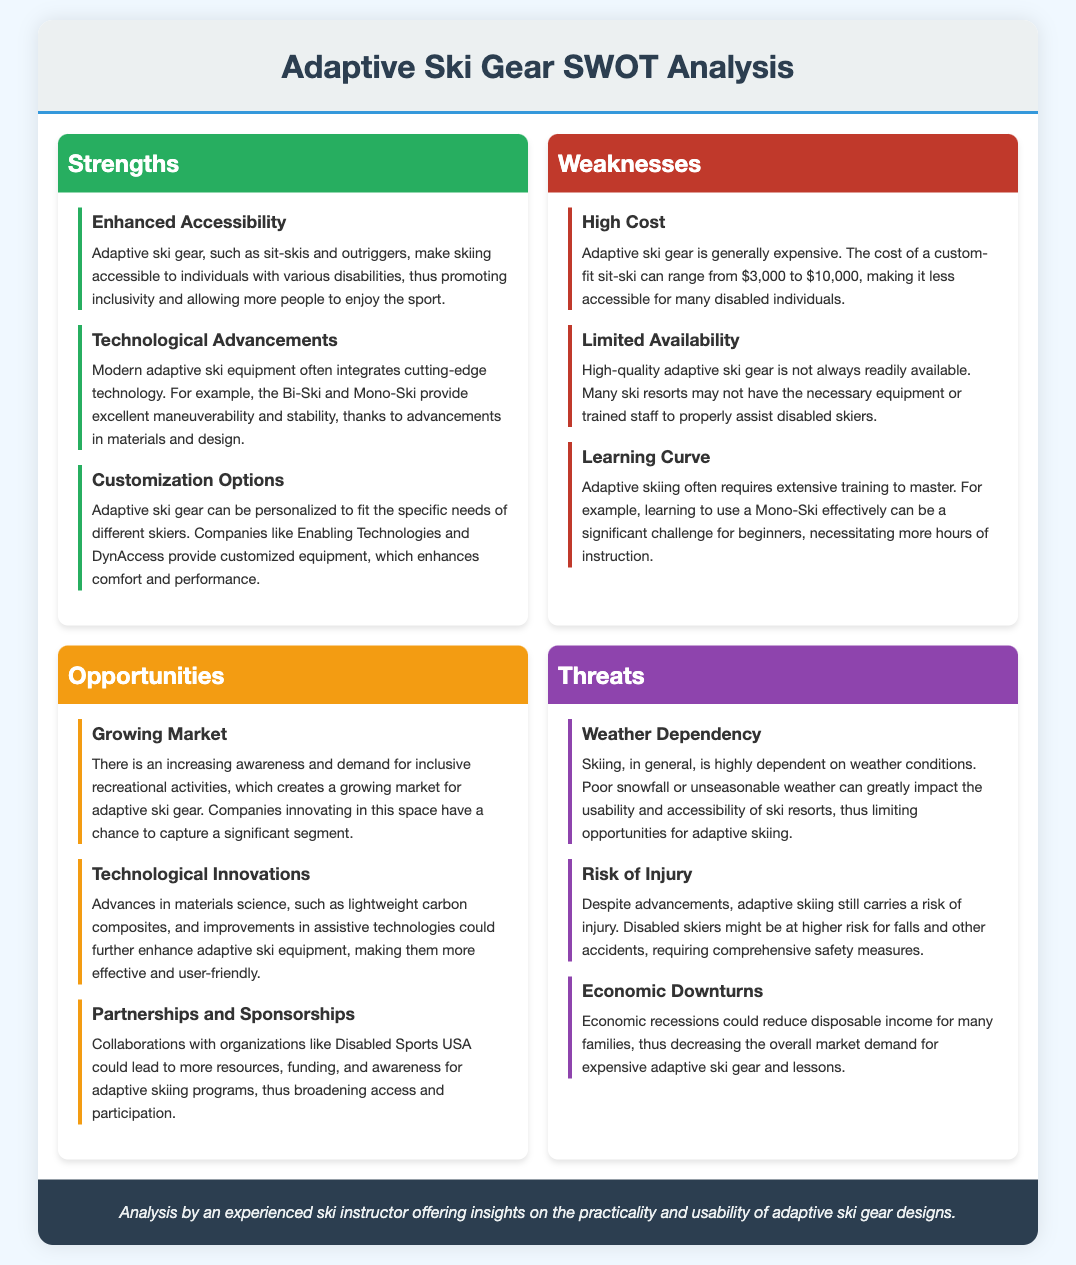What is a key benefit of adaptive ski gear? Enhanced accessibility is highlighted as a significant advantage of adaptive ski gear, making skiing enjoyable for individuals with disabilities.
Answer: Enhanced accessibility What is the cost range for a custom-fit sit-ski? The document specifies that the cost of a custom-fit sit-ski can range from $3,000 to $10,000, indicating a substantial financial investment.
Answer: $3,000 to $10,000 Which organization could lead to increased awareness for adaptive skiing? The document mentions Disabled Sports USA as a potential collaborator that could enhance resources and awareness for adaptive skiing programs.
Answer: Disabled Sports USA What is a technological advancement mentioned in the document? The Bi-Ski and Mono-Ski are examples of modern adaptive equipment that incorporate cutting-edge technology for improved performance.
Answer: Bi-Ski and Mono-Ski What is a significant challenge faced by beginners in adaptive skiing? The document notes that a learning curve is involved, stating that mastering the use of a Mono-Ski can be particularly challenging for newcomers.
Answer: Learning curve 